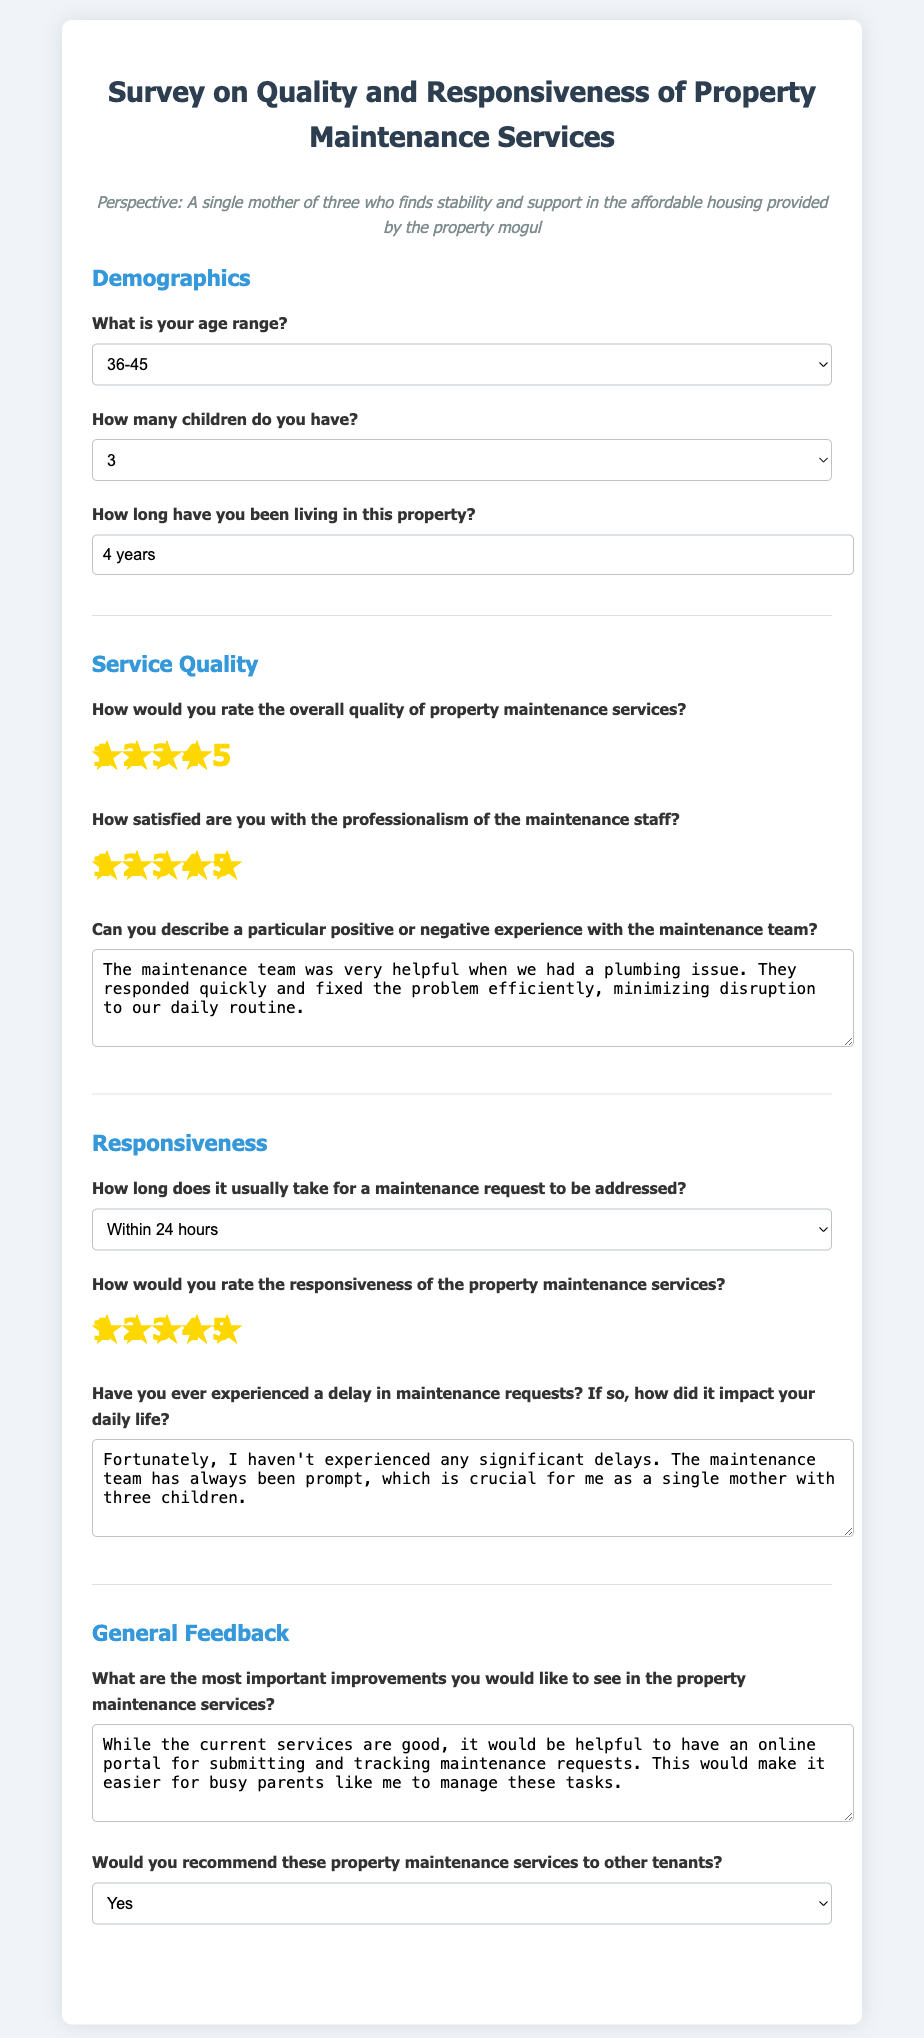What is your age range? The document includes a dropdown list where respondents can select their age range. The selected option here is "36-45".
Answer: 36-45 How many children do you have? There is a question about the number of children with a selected option of "3".
Answer: 3 How long have you been living in this property? The form allows a text entry for duration, where the response given is "4 years".
Answer: 4 years How would you rate the overall quality of property maintenance services? Respondents can select a star rating on a scale of 1 to 5; the selected rating here is "4".
Answer: 4 How long does it usually take for a maintenance request to be addressed? This question offers options for response; the selected option is "Within 24 hours".
Answer: Within 24 hours Have you ever experienced a delay in maintenance requests? Respondents answer a yes or no question; the respondent indicated that they haven't experienced significant delays.
Answer: No What are the most important improvements you would like to see in the property maintenance services? The document includes an open-ended question, and the feedback provided suggests an online portal for requests.
Answer: Online portal for requests Would you recommend these property maintenance services to other tenants? There is a question that offers a yes or no option; the selected answer is "Yes".
Answer: Yes 